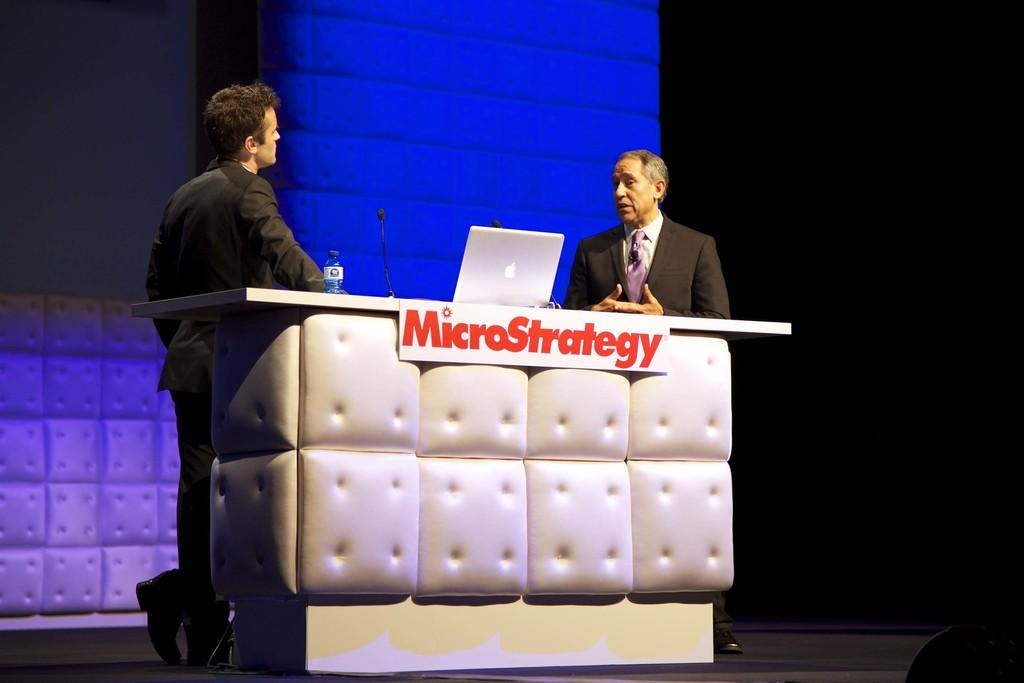How many people are in the image? There are two persons in the image. What are the two persons doing in the image? The two persons are standing in front of a table. What objects can be seen on the table? There is a laptop, a water bottle, and mics on the table. What is visible in the background of the image? There is a wall in the background of the image. Can you tell me how many robins are sitting on the laptop in the image? There are no robins present in the image; it features two people standing in front of a table with a laptop, water bottle, and mics. What type of nerve is visible on the table in the image? There is no nerve visible on the table in the image; it features a laptop, water bottle, and mics. 